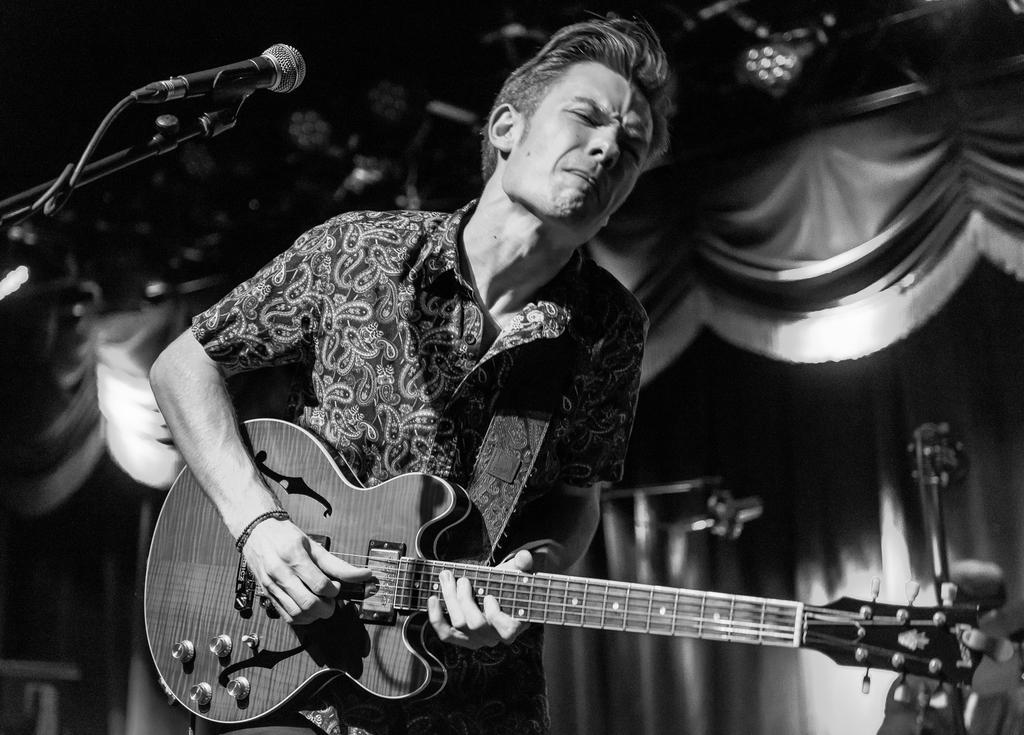What is the man in the image doing? The man is playing a guitar. What object is present in the image that is typically used for amplifying sound? There is a microphone in the image. What type of holiday is the man celebrating in the image? There is no indication of a holiday in the image; it simply shows a man playing a guitar and a microphone. What type of lock is visible on the guitar in the image? There is no lock visible on the guitar in the image. What type of vessel is the man using to transport water in the image? There is no vessel present in the image, nor is there any indication of water transportation. 